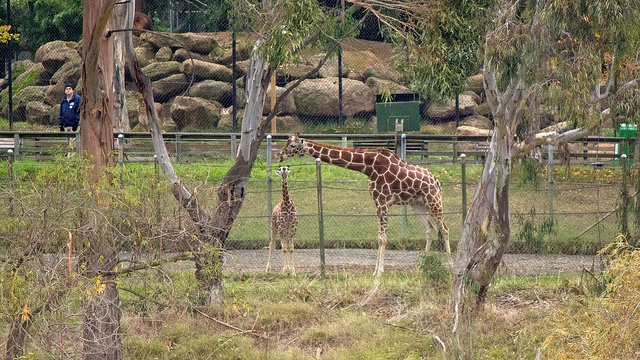Describe the objects in this image and their specific colors. I can see giraffe in black, maroon, gray, and tan tones, giraffe in black, tan, and gray tones, people in black, navy, gray, and darkblue tones, bench in black and gray tones, and bench in black, gray, darkgray, and lightgray tones in this image. 